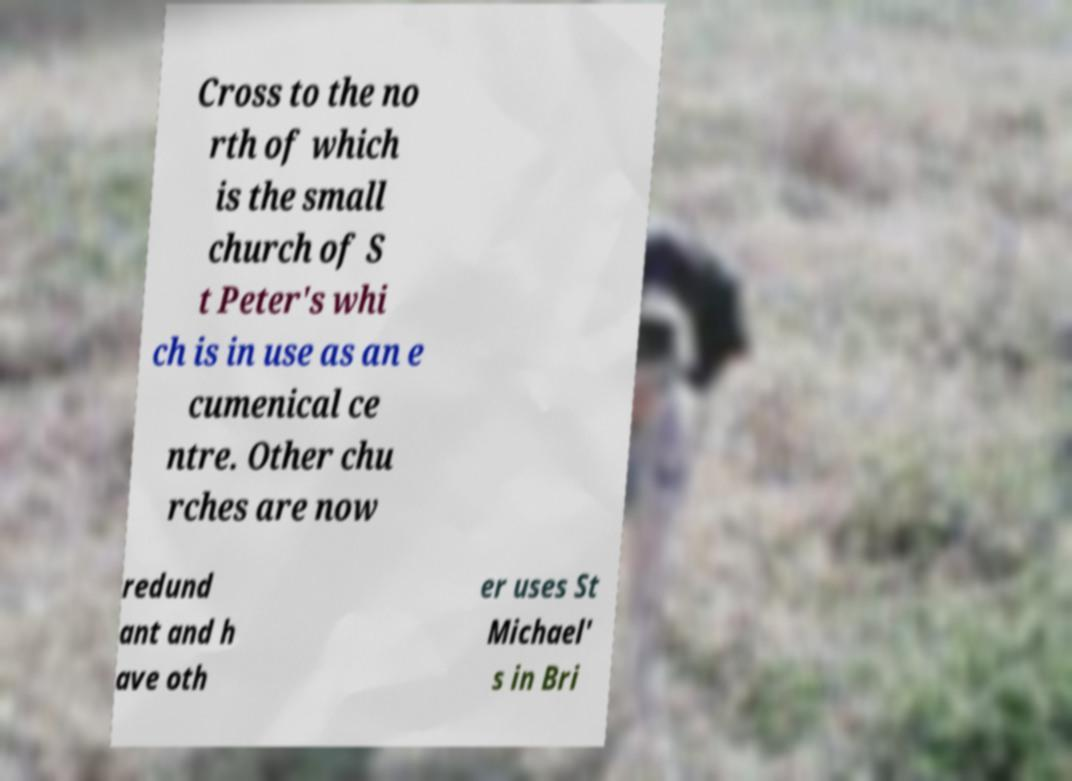Please identify and transcribe the text found in this image. Cross to the no rth of which is the small church of S t Peter's whi ch is in use as an e cumenical ce ntre. Other chu rches are now redund ant and h ave oth er uses St Michael' s in Bri 